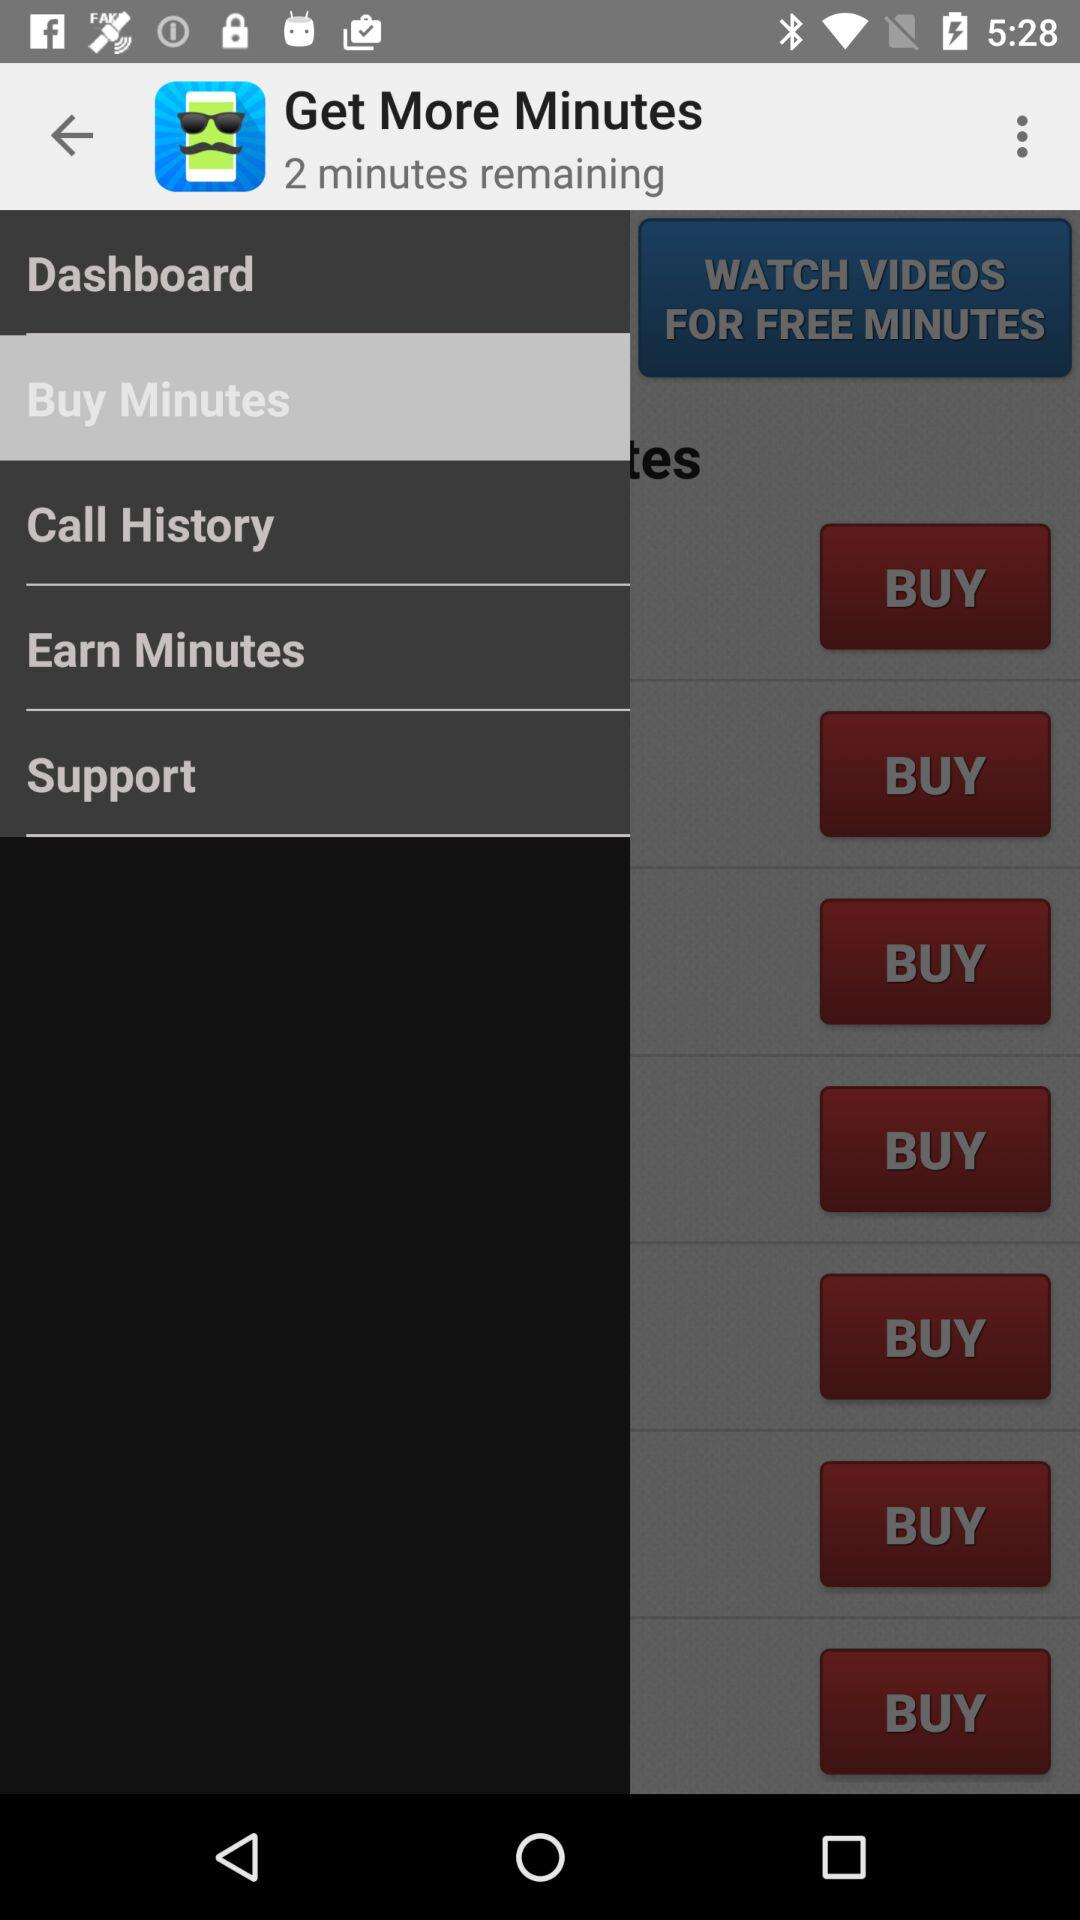Which item is selected? The selected item is "Buy Minutes". 